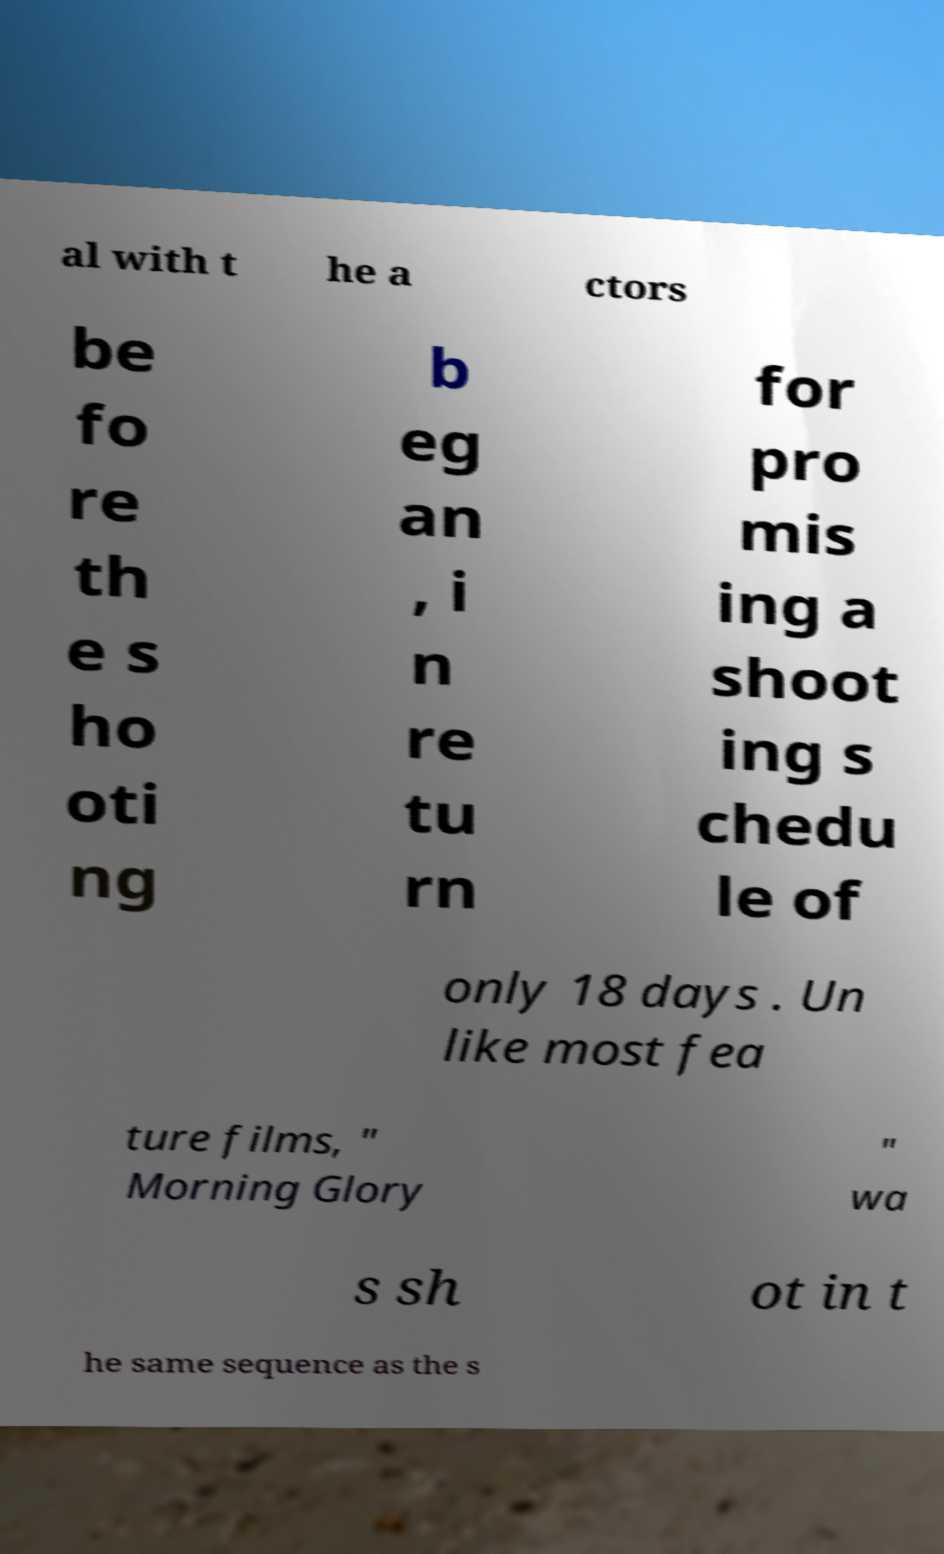I need the written content from this picture converted into text. Can you do that? al with t he a ctors be fo re th e s ho oti ng b eg an , i n re tu rn for pro mis ing a shoot ing s chedu le of only 18 days . Un like most fea ture films, " Morning Glory " wa s sh ot in t he same sequence as the s 